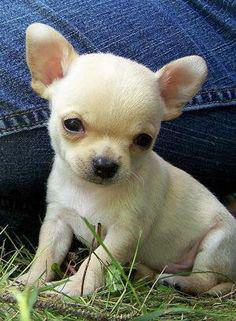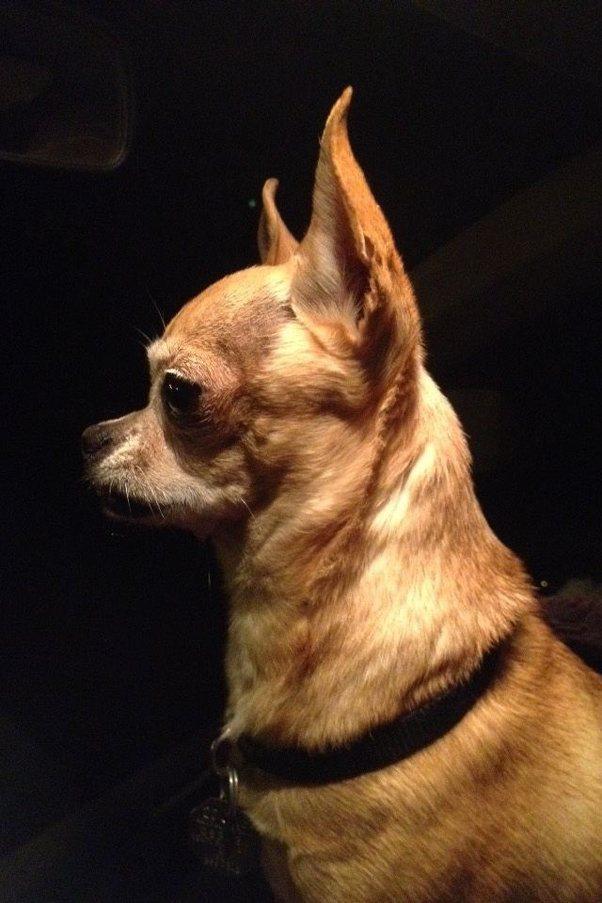The first image is the image on the left, the second image is the image on the right. For the images displayed, is the sentence "A person is holding the dog in the image on the right." factually correct? Answer yes or no. No. The first image is the image on the left, the second image is the image on the right. For the images displayed, is the sentence "The dog in the image on the right is being held by a human." factually correct? Answer yes or no. No. 